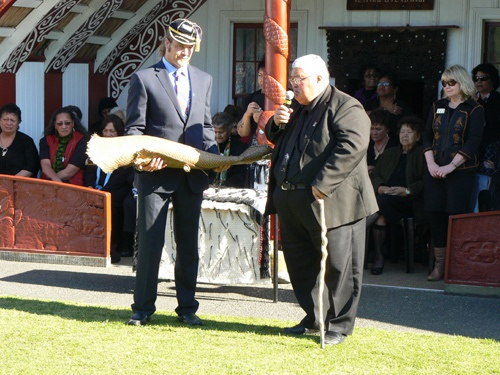Describe the objects in this image and their specific colors. I can see people in brown, black, darkgray, gray, and ivory tones, people in brown, black, darkgray, gray, and white tones, people in brown, black, gray, and maroon tones, people in brown, black, and gray tones, and people in brown, black, gray, and maroon tones in this image. 